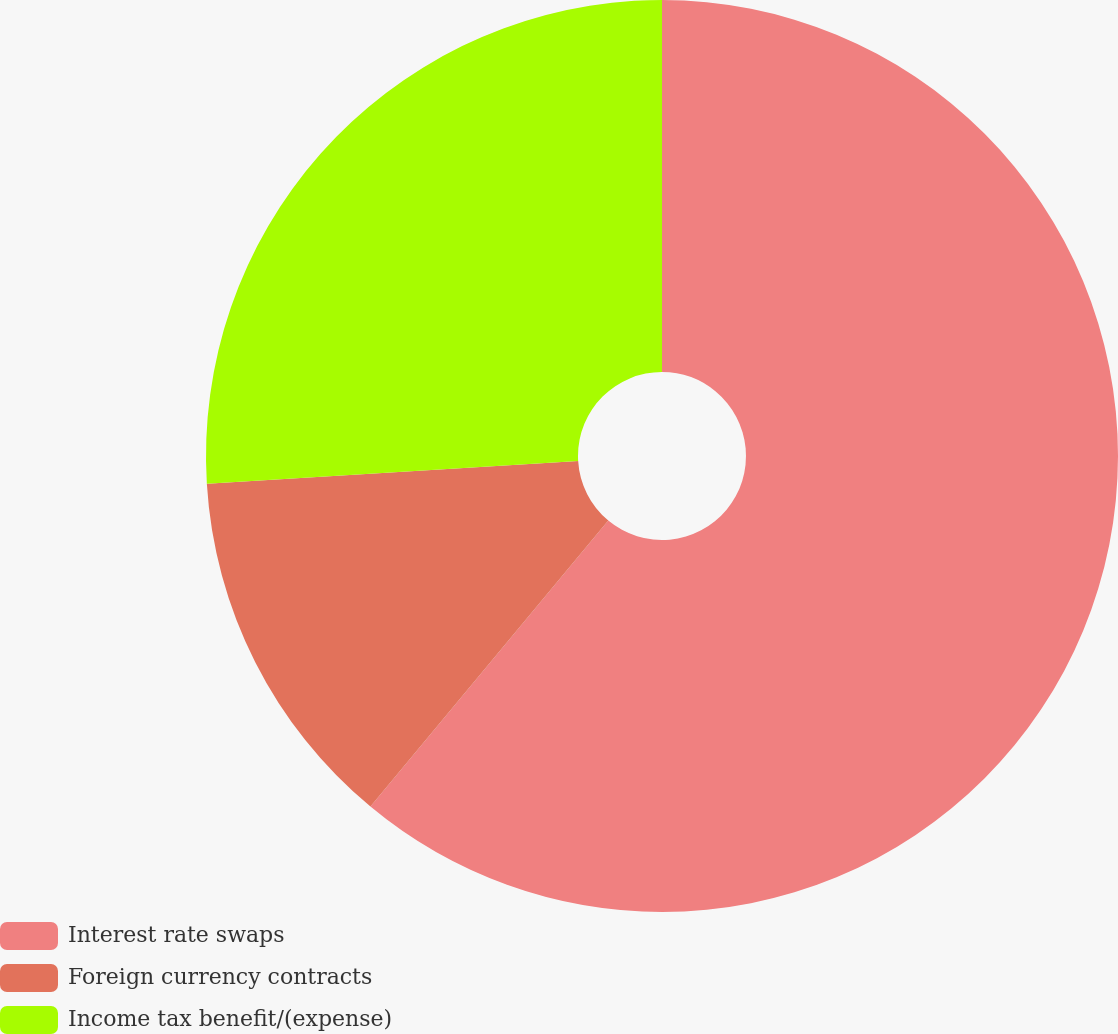<chart> <loc_0><loc_0><loc_500><loc_500><pie_chart><fcel>Interest rate swaps<fcel>Foreign currency contracts<fcel>Income tax benefit/(expense)<nl><fcel>61.04%<fcel>12.99%<fcel>25.97%<nl></chart> 